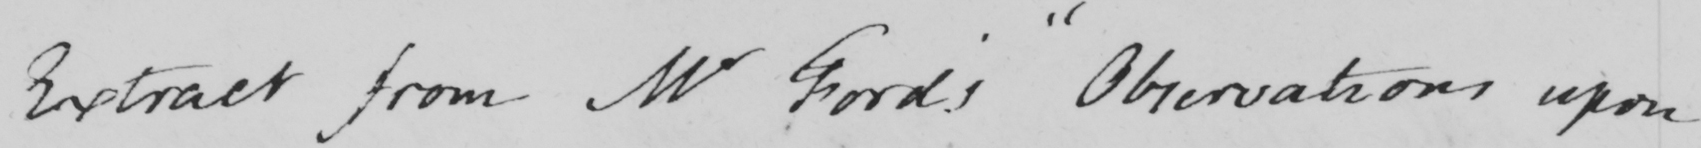Can you read and transcribe this handwriting? Extract from Mr Ford ' s  " Observations upon 